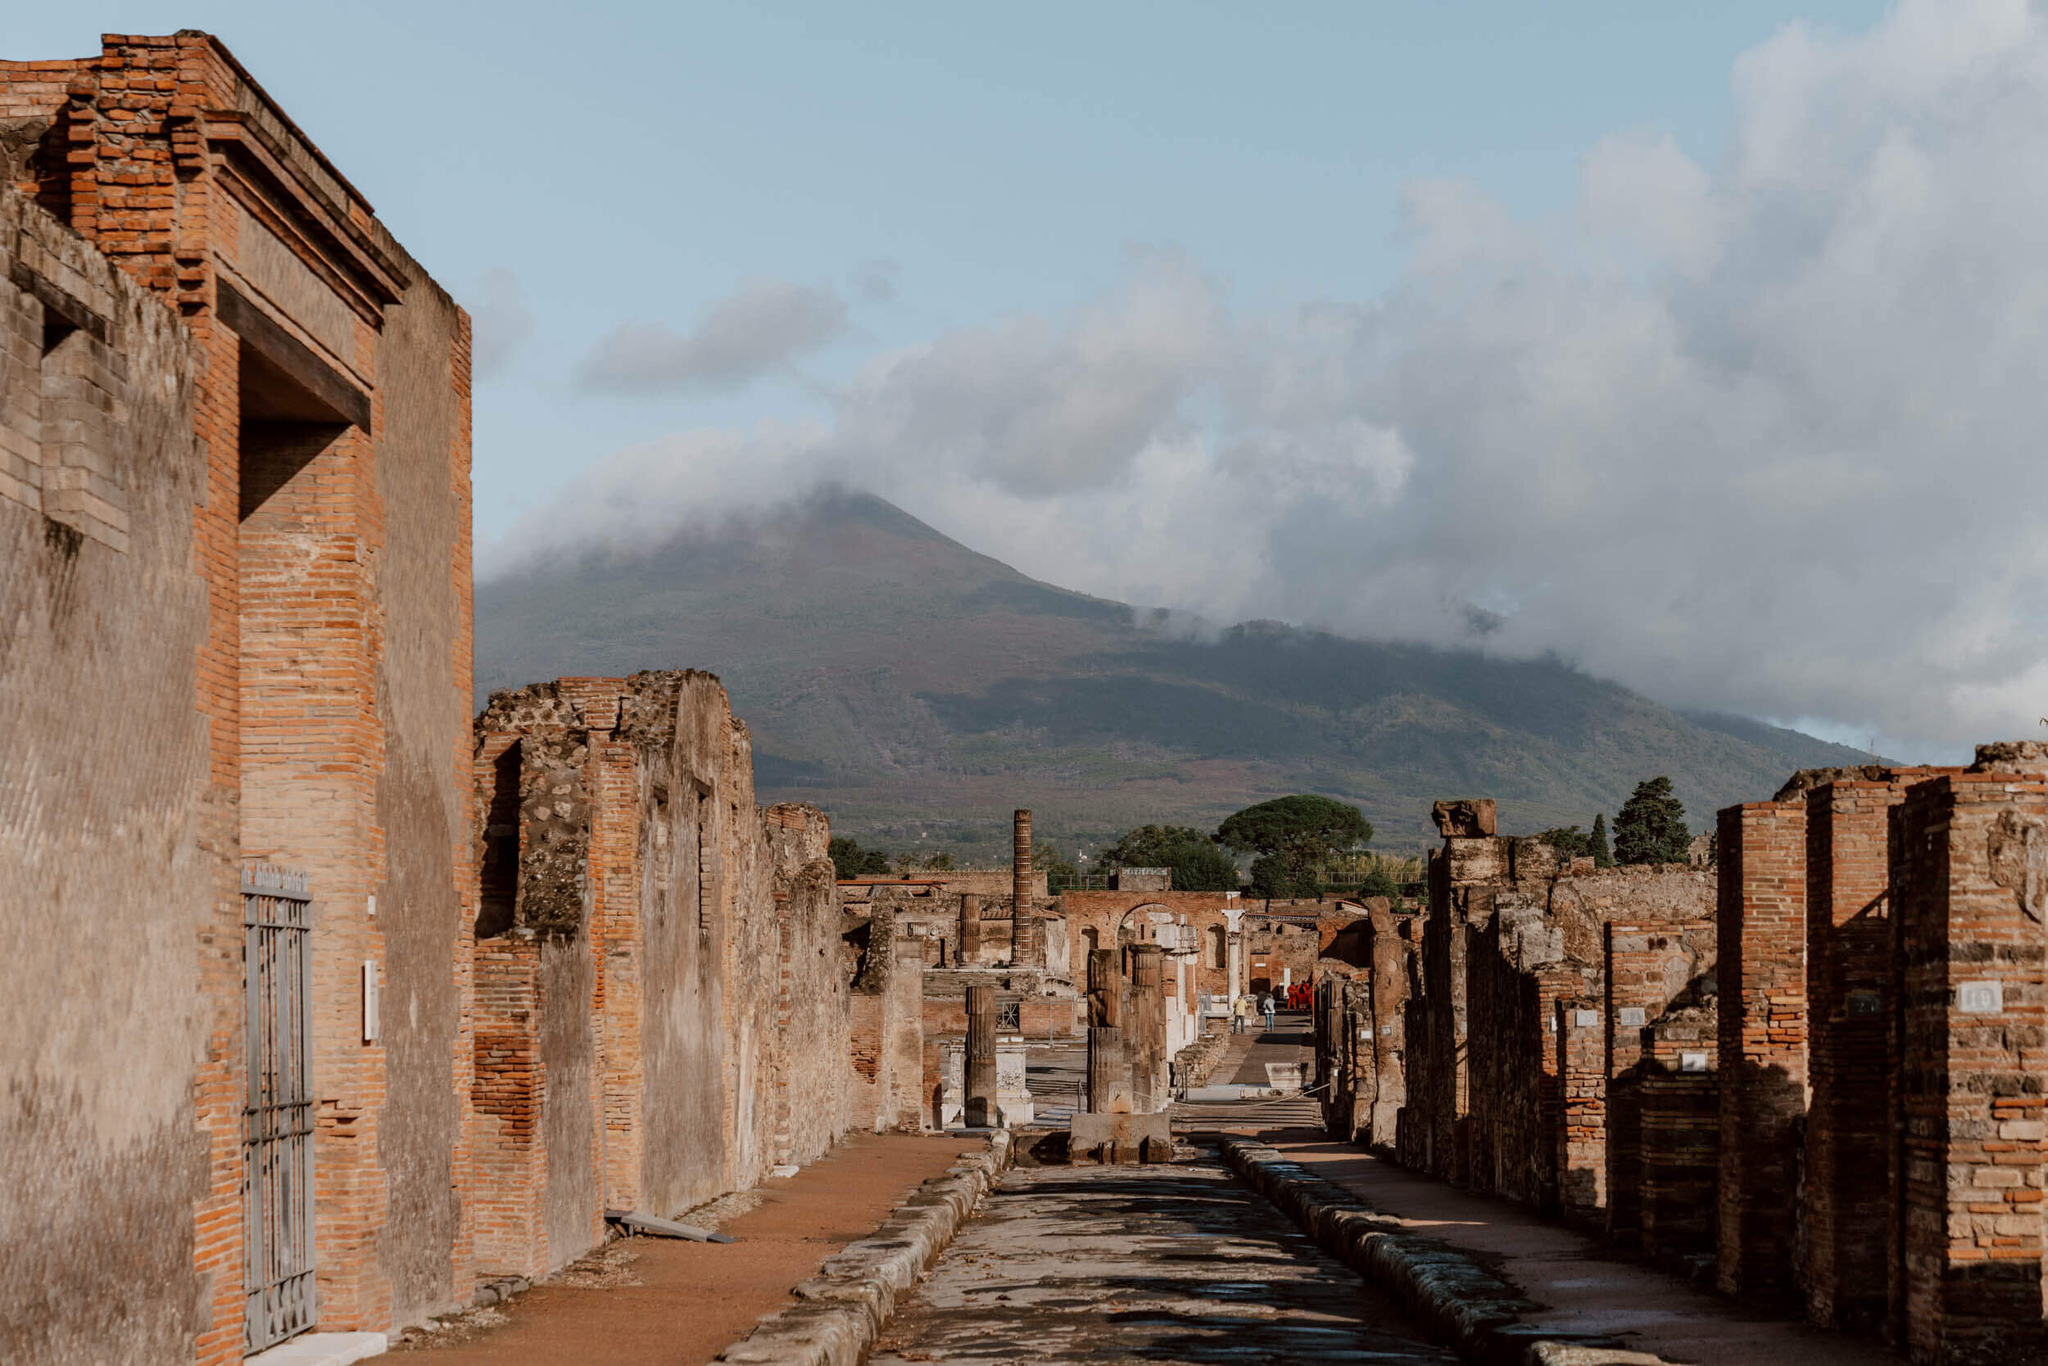If you were to write an epic tale inspired by Pompeii, what would be the main plot? In an epic tale inspired by Pompeii, the story would revolve around the lives of two star-crossed lovers from different social strata, whose destinies intertwine against the backdrop of the vibrant yet turbulent city. The protagonist, Aelius, a skilled metalworker born to a modest family, crosses paths with Livia, the daughter of a wealthy senator, during a festival. Their forbidden love blossoms in secret as they navigate the complexities of their societal roles.

Unbeknownst to them, the shadow of Mount Vesuvius looms ever closer, with signs of an impending eruption beginning to surface. Amid the rising tension, Aelius stumbles upon an ancient prophecy foretelling the disaster and realizes the urgency to save the city and their love. Together, they embark on a quest into the heart of the volcano, seeking a fabled artifact rumored to possess the power to quell the mountain's wrath.

Their journey is fraught with trials and tribulations, from facing treacherous terrains to battling mythical guardians. Along the way, they uncover deeper secrets about their ancestors, connecting their fates to the city's origins. As the eruption grows imminent, Aelius and Livia return to Pompeii, rallying the citizens and leading a daring evacuation, defying the constraints of their societal divide.

The tale culminates in a dramatic confrontation with the volatile forces of nature. Though the artifact fails to stop the eruption, it channels the destructive energy away from the city, sparing most of its inhabitants. The lovers, in a poignant act of sacrifice, fuse their spirits with the ancient energy, becoming eternal guardians of Pompeii.

Years later, the tale of Aelius and Livia evolves into legend, reminding future generations of their bravery, love, and the enduring spirit of a city reborn from ashes. Realistic Reflection: What would be a short description of the ruins of Pompeii as seen in the image for a travel guide? The ruins of Pompeii, as seen in the image, offer a haunting yet fascinating glimpse into ancient Roman life. Strolling down the well-preserved streets, flanked by aged brick buildings, you can almost hear the echoes of a once-thriving city. The silhouette of Mount Vesuvius looms in the distance, a testament to the volcanic fury that forever changed this place. As you explore, you'll encounter remnants of homes, shops, and public spaces, all frozen in time, providing an unparalleled journey through history. A visit to Pompeii is a poignant reminder of nature's power and the enduring legacy of human resilience. 